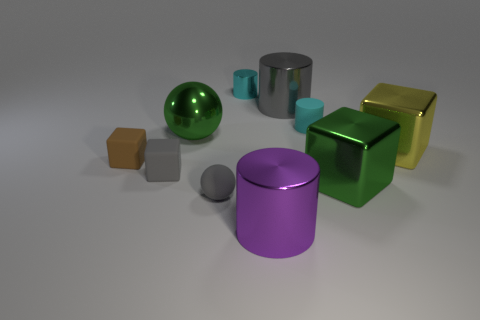Subtract all big green cubes. How many cubes are left? 3 Subtract all balls. How many objects are left? 8 Add 2 tiny cylinders. How many tiny cylinders are left? 4 Add 6 gray metal things. How many gray metal things exist? 7 Subtract all gray balls. How many balls are left? 1 Subtract 0 purple cubes. How many objects are left? 10 Subtract all purple cylinders. Subtract all red spheres. How many cylinders are left? 3 Subtract all green balls. How many brown cubes are left? 1 Subtract all gray shiny objects. Subtract all gray metallic cylinders. How many objects are left? 8 